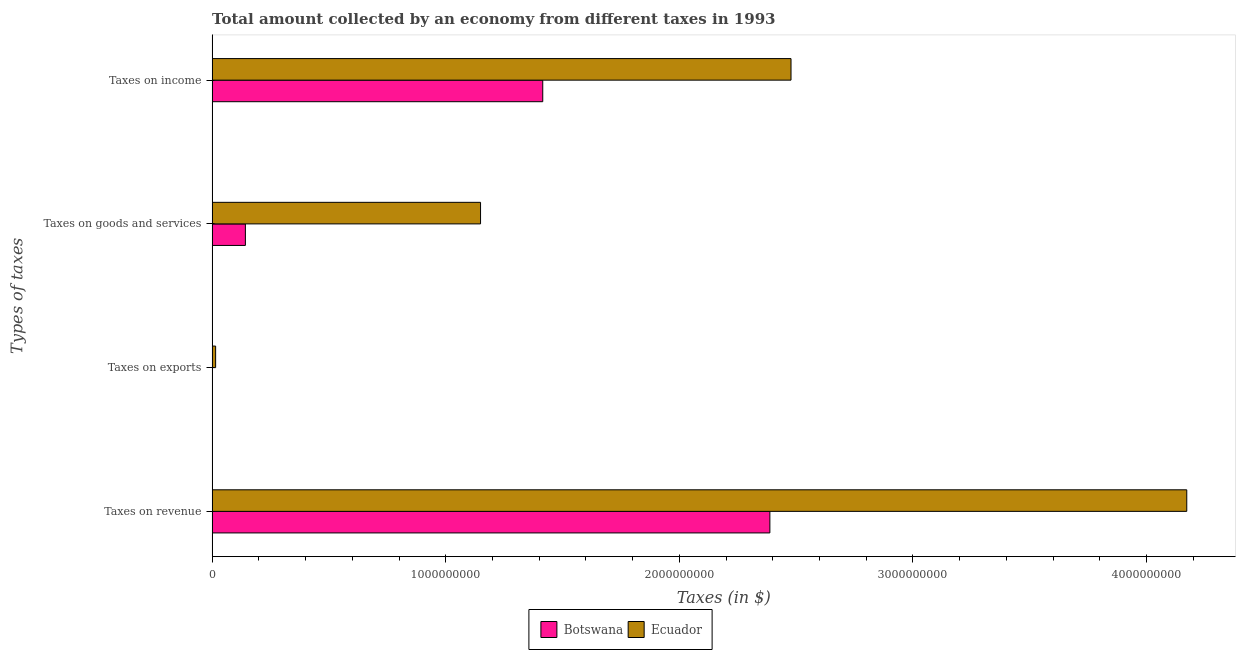How many different coloured bars are there?
Provide a short and direct response. 2. Are the number of bars per tick equal to the number of legend labels?
Keep it short and to the point. Yes. What is the label of the 2nd group of bars from the top?
Provide a succinct answer. Taxes on goods and services. What is the amount collected as tax on goods in Ecuador?
Give a very brief answer. 1.15e+09. Across all countries, what is the maximum amount collected as tax on exports?
Keep it short and to the point. 1.50e+07. Across all countries, what is the minimum amount collected as tax on exports?
Provide a succinct answer. 5.00e+05. In which country was the amount collected as tax on income maximum?
Keep it short and to the point. Ecuador. In which country was the amount collected as tax on goods minimum?
Make the answer very short. Botswana. What is the total amount collected as tax on income in the graph?
Ensure brevity in your answer.  3.89e+09. What is the difference between the amount collected as tax on revenue in Botswana and that in Ecuador?
Your response must be concise. -1.78e+09. What is the difference between the amount collected as tax on revenue in Botswana and the amount collected as tax on goods in Ecuador?
Provide a succinct answer. 1.24e+09. What is the average amount collected as tax on exports per country?
Give a very brief answer. 7.75e+06. What is the difference between the amount collected as tax on income and amount collected as tax on goods in Botswana?
Your answer should be very brief. 1.27e+09. In how many countries, is the amount collected as tax on revenue greater than 1600000000 $?
Ensure brevity in your answer.  2. What is the ratio of the amount collected as tax on revenue in Botswana to that in Ecuador?
Your answer should be compact. 0.57. What is the difference between the highest and the second highest amount collected as tax on goods?
Give a very brief answer. 1.01e+09. What is the difference between the highest and the lowest amount collected as tax on revenue?
Your answer should be very brief. 1.78e+09. In how many countries, is the amount collected as tax on goods greater than the average amount collected as tax on goods taken over all countries?
Your answer should be compact. 1. What does the 1st bar from the top in Taxes on exports represents?
Offer a very short reply. Ecuador. What does the 1st bar from the bottom in Taxes on exports represents?
Offer a terse response. Botswana. How many countries are there in the graph?
Your answer should be very brief. 2. What is the difference between two consecutive major ticks on the X-axis?
Provide a succinct answer. 1.00e+09. Does the graph contain grids?
Your answer should be very brief. No. Where does the legend appear in the graph?
Your answer should be compact. Bottom center. What is the title of the graph?
Provide a short and direct response. Total amount collected by an economy from different taxes in 1993. Does "Honduras" appear as one of the legend labels in the graph?
Provide a succinct answer. No. What is the label or title of the X-axis?
Your answer should be compact. Taxes (in $). What is the label or title of the Y-axis?
Give a very brief answer. Types of taxes. What is the Taxes (in $) of Botswana in Taxes on revenue?
Your response must be concise. 2.39e+09. What is the Taxes (in $) in Ecuador in Taxes on revenue?
Offer a very short reply. 4.17e+09. What is the Taxes (in $) in Botswana in Taxes on exports?
Provide a succinct answer. 5.00e+05. What is the Taxes (in $) in Ecuador in Taxes on exports?
Your answer should be very brief. 1.50e+07. What is the Taxes (in $) in Botswana in Taxes on goods and services?
Provide a short and direct response. 1.42e+08. What is the Taxes (in $) in Ecuador in Taxes on goods and services?
Offer a very short reply. 1.15e+09. What is the Taxes (in $) in Botswana in Taxes on income?
Your response must be concise. 1.42e+09. What is the Taxes (in $) in Ecuador in Taxes on income?
Ensure brevity in your answer.  2.48e+09. Across all Types of taxes, what is the maximum Taxes (in $) in Botswana?
Ensure brevity in your answer.  2.39e+09. Across all Types of taxes, what is the maximum Taxes (in $) in Ecuador?
Provide a succinct answer. 4.17e+09. Across all Types of taxes, what is the minimum Taxes (in $) in Botswana?
Your answer should be compact. 5.00e+05. Across all Types of taxes, what is the minimum Taxes (in $) in Ecuador?
Give a very brief answer. 1.50e+07. What is the total Taxes (in $) in Botswana in the graph?
Your response must be concise. 3.95e+09. What is the total Taxes (in $) in Ecuador in the graph?
Your response must be concise. 7.81e+09. What is the difference between the Taxes (in $) of Botswana in Taxes on revenue and that in Taxes on exports?
Give a very brief answer. 2.39e+09. What is the difference between the Taxes (in $) in Ecuador in Taxes on revenue and that in Taxes on exports?
Offer a terse response. 4.16e+09. What is the difference between the Taxes (in $) in Botswana in Taxes on revenue and that in Taxes on goods and services?
Offer a terse response. 2.25e+09. What is the difference between the Taxes (in $) in Ecuador in Taxes on revenue and that in Taxes on goods and services?
Ensure brevity in your answer.  3.02e+09. What is the difference between the Taxes (in $) in Botswana in Taxes on revenue and that in Taxes on income?
Keep it short and to the point. 9.72e+08. What is the difference between the Taxes (in $) of Ecuador in Taxes on revenue and that in Taxes on income?
Provide a succinct answer. 1.69e+09. What is the difference between the Taxes (in $) of Botswana in Taxes on exports and that in Taxes on goods and services?
Make the answer very short. -1.42e+08. What is the difference between the Taxes (in $) of Ecuador in Taxes on exports and that in Taxes on goods and services?
Keep it short and to the point. -1.13e+09. What is the difference between the Taxes (in $) in Botswana in Taxes on exports and that in Taxes on income?
Keep it short and to the point. -1.41e+09. What is the difference between the Taxes (in $) in Ecuador in Taxes on exports and that in Taxes on income?
Your answer should be very brief. -2.46e+09. What is the difference between the Taxes (in $) of Botswana in Taxes on goods and services and that in Taxes on income?
Your answer should be very brief. -1.27e+09. What is the difference between the Taxes (in $) of Ecuador in Taxes on goods and services and that in Taxes on income?
Your answer should be very brief. -1.33e+09. What is the difference between the Taxes (in $) of Botswana in Taxes on revenue and the Taxes (in $) of Ecuador in Taxes on exports?
Your answer should be compact. 2.37e+09. What is the difference between the Taxes (in $) in Botswana in Taxes on revenue and the Taxes (in $) in Ecuador in Taxes on goods and services?
Your answer should be compact. 1.24e+09. What is the difference between the Taxes (in $) of Botswana in Taxes on revenue and the Taxes (in $) of Ecuador in Taxes on income?
Offer a very short reply. -9.05e+07. What is the difference between the Taxes (in $) in Botswana in Taxes on exports and the Taxes (in $) in Ecuador in Taxes on goods and services?
Your answer should be very brief. -1.15e+09. What is the difference between the Taxes (in $) in Botswana in Taxes on exports and the Taxes (in $) in Ecuador in Taxes on income?
Offer a terse response. -2.48e+09. What is the difference between the Taxes (in $) in Botswana in Taxes on goods and services and the Taxes (in $) in Ecuador in Taxes on income?
Offer a very short reply. -2.34e+09. What is the average Taxes (in $) in Botswana per Types of taxes?
Provide a succinct answer. 9.86e+08. What is the average Taxes (in $) in Ecuador per Types of taxes?
Ensure brevity in your answer.  1.95e+09. What is the difference between the Taxes (in $) in Botswana and Taxes (in $) in Ecuador in Taxes on revenue?
Ensure brevity in your answer.  -1.78e+09. What is the difference between the Taxes (in $) of Botswana and Taxes (in $) of Ecuador in Taxes on exports?
Provide a short and direct response. -1.45e+07. What is the difference between the Taxes (in $) in Botswana and Taxes (in $) in Ecuador in Taxes on goods and services?
Offer a terse response. -1.01e+09. What is the difference between the Taxes (in $) of Botswana and Taxes (in $) of Ecuador in Taxes on income?
Give a very brief answer. -1.06e+09. What is the ratio of the Taxes (in $) in Botswana in Taxes on revenue to that in Taxes on exports?
Your response must be concise. 4775. What is the ratio of the Taxes (in $) in Ecuador in Taxes on revenue to that in Taxes on exports?
Give a very brief answer. 278.13. What is the ratio of the Taxes (in $) of Botswana in Taxes on revenue to that in Taxes on goods and services?
Make the answer very short. 16.77. What is the ratio of the Taxes (in $) in Ecuador in Taxes on revenue to that in Taxes on goods and services?
Offer a terse response. 3.63. What is the ratio of the Taxes (in $) in Botswana in Taxes on revenue to that in Taxes on income?
Your response must be concise. 1.69. What is the ratio of the Taxes (in $) in Ecuador in Taxes on revenue to that in Taxes on income?
Offer a very short reply. 1.68. What is the ratio of the Taxes (in $) of Botswana in Taxes on exports to that in Taxes on goods and services?
Make the answer very short. 0. What is the ratio of the Taxes (in $) of Ecuador in Taxes on exports to that in Taxes on goods and services?
Keep it short and to the point. 0.01. What is the ratio of the Taxes (in $) in Botswana in Taxes on exports to that in Taxes on income?
Offer a very short reply. 0. What is the ratio of the Taxes (in $) of Ecuador in Taxes on exports to that in Taxes on income?
Provide a short and direct response. 0.01. What is the ratio of the Taxes (in $) of Botswana in Taxes on goods and services to that in Taxes on income?
Keep it short and to the point. 0.1. What is the ratio of the Taxes (in $) in Ecuador in Taxes on goods and services to that in Taxes on income?
Keep it short and to the point. 0.46. What is the difference between the highest and the second highest Taxes (in $) in Botswana?
Your answer should be very brief. 9.72e+08. What is the difference between the highest and the second highest Taxes (in $) of Ecuador?
Your response must be concise. 1.69e+09. What is the difference between the highest and the lowest Taxes (in $) of Botswana?
Offer a very short reply. 2.39e+09. What is the difference between the highest and the lowest Taxes (in $) in Ecuador?
Provide a succinct answer. 4.16e+09. 